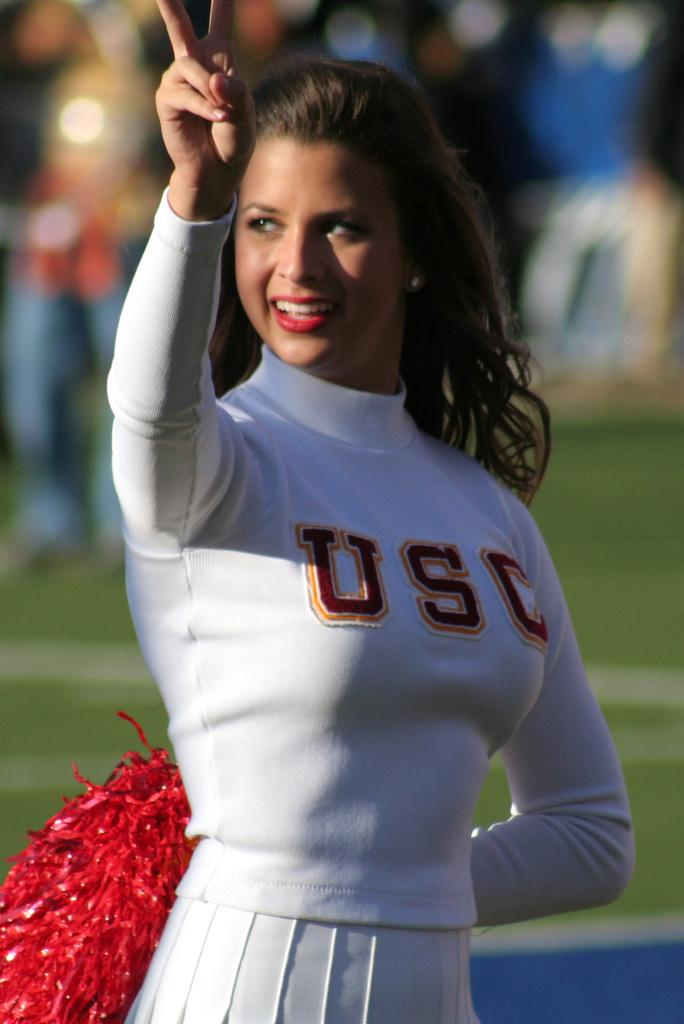<image>
Offer a succinct explanation of the picture presented. Cheerleading giving a peace sign wearing a USC outfit. 